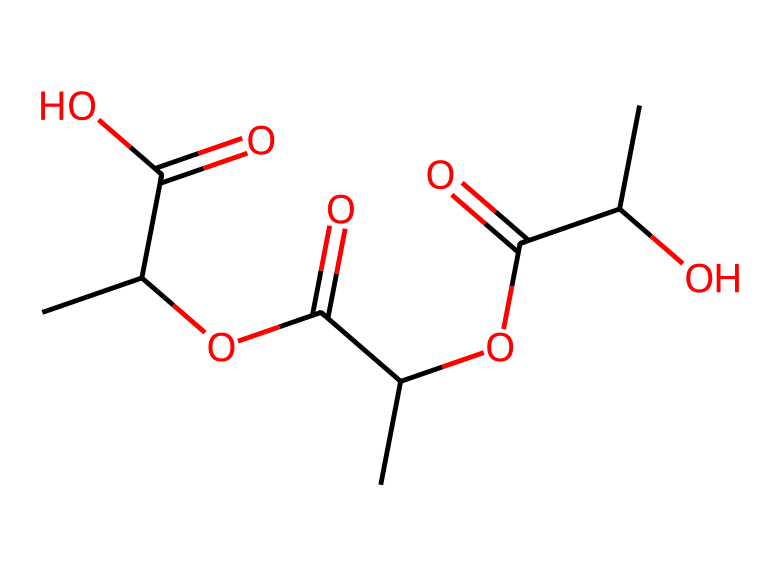What is the main functional group present in this structure? The main functional group in the given structure is the ester group, which appears multiple times in the form -C(=O)O-. This indicates that the molecule consists of ester linkages derived from lactic acid.
Answer: ester How many carbon atoms are present in the molecule? By analyzing the SMILES representation, we can count the number of 'C' characters, which indicates the number of carbon atoms. In this structure, there are 7 carbon atoms in total.
Answer: 7 What type of polymer is represented by this structure? This chemical structure is indicative of a polymer known as polylactic acid (PLA), which is a biodegradable polyester derived from lactic acid.
Answer: biodegradable polyester How many hydroxyl (-OH) groups can be found in this chemical structure? Upon reviewing the structure, we can see one hydroxyl group in the terminal part of the molecule, indicating that there is one -OH group present.
Answer: 1 Does this structure contain any rings? By examining the visual structure, we note that there are no cyclic components or rings involved in the arrangement of this molecule. The structure is linear without any ring formation.
Answer: no What is the approximate molecular weight of polylactic acid based on its structural formula? To estimate molecular weight, we calculate based on the individual atoms: Carbon (C) contributes 12.01 g/mol, Oxygen (O) contributes 16.00 g/mol, and Hydrogen (H) contributes 1.008 g/mol. Summing these contributions of the atoms gives an approximate molecular weight of around 72.06 g/mol for this compound.
Answer: 72.06 